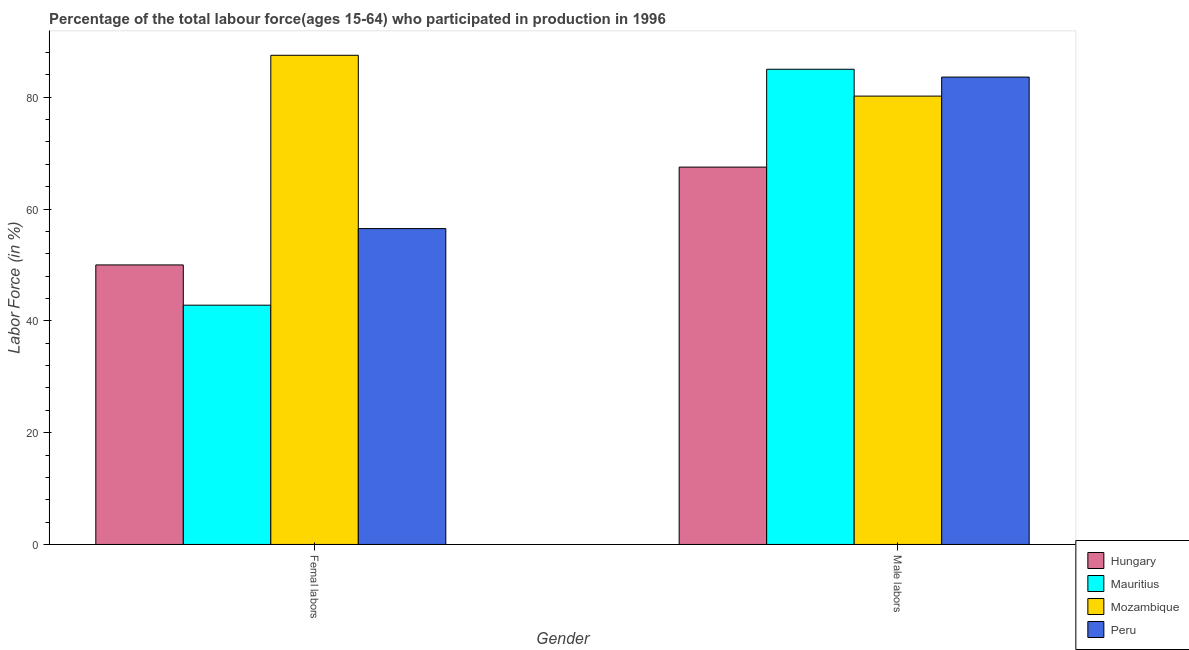How many groups of bars are there?
Offer a terse response. 2. Are the number of bars per tick equal to the number of legend labels?
Give a very brief answer. Yes. What is the label of the 2nd group of bars from the left?
Your response must be concise. Male labors. What is the percentage of female labor force in Peru?
Your answer should be compact. 56.5. Across all countries, what is the maximum percentage of female labor force?
Your response must be concise. 87.5. Across all countries, what is the minimum percentage of male labour force?
Offer a very short reply. 67.5. In which country was the percentage of female labor force maximum?
Give a very brief answer. Mozambique. In which country was the percentage of male labour force minimum?
Ensure brevity in your answer.  Hungary. What is the total percentage of female labor force in the graph?
Offer a very short reply. 236.8. What is the difference between the percentage of male labour force in Mauritius and that in Mozambique?
Make the answer very short. 4.8. What is the difference between the percentage of male labour force in Mozambique and the percentage of female labor force in Peru?
Ensure brevity in your answer.  23.7. What is the average percentage of female labor force per country?
Give a very brief answer. 59.2. What is the difference between the percentage of male labour force and percentage of female labor force in Hungary?
Provide a succinct answer. 17.5. In how many countries, is the percentage of female labor force greater than 28 %?
Give a very brief answer. 4. What is the ratio of the percentage of female labor force in Hungary to that in Peru?
Keep it short and to the point. 0.88. Is the percentage of male labour force in Hungary less than that in Mozambique?
Provide a succinct answer. Yes. What does the 2nd bar from the left in Male labors represents?
Ensure brevity in your answer.  Mauritius. What does the 1st bar from the right in Femal labors represents?
Your answer should be very brief. Peru. How many bars are there?
Your response must be concise. 8. What is the difference between two consecutive major ticks on the Y-axis?
Ensure brevity in your answer.  20. Does the graph contain grids?
Keep it short and to the point. No. How many legend labels are there?
Make the answer very short. 4. What is the title of the graph?
Your answer should be very brief. Percentage of the total labour force(ages 15-64) who participated in production in 1996. Does "Turkey" appear as one of the legend labels in the graph?
Your answer should be compact. No. What is the label or title of the X-axis?
Ensure brevity in your answer.  Gender. What is the label or title of the Y-axis?
Your answer should be very brief. Labor Force (in %). What is the Labor Force (in %) of Mauritius in Femal labors?
Your response must be concise. 42.8. What is the Labor Force (in %) in Mozambique in Femal labors?
Offer a terse response. 87.5. What is the Labor Force (in %) in Peru in Femal labors?
Your answer should be very brief. 56.5. What is the Labor Force (in %) in Hungary in Male labors?
Make the answer very short. 67.5. What is the Labor Force (in %) of Mauritius in Male labors?
Provide a short and direct response. 85. What is the Labor Force (in %) in Mozambique in Male labors?
Provide a succinct answer. 80.2. What is the Labor Force (in %) in Peru in Male labors?
Offer a very short reply. 83.6. Across all Gender, what is the maximum Labor Force (in %) in Hungary?
Provide a succinct answer. 67.5. Across all Gender, what is the maximum Labor Force (in %) of Mauritius?
Your answer should be very brief. 85. Across all Gender, what is the maximum Labor Force (in %) in Mozambique?
Keep it short and to the point. 87.5. Across all Gender, what is the maximum Labor Force (in %) of Peru?
Your response must be concise. 83.6. Across all Gender, what is the minimum Labor Force (in %) in Mauritius?
Keep it short and to the point. 42.8. Across all Gender, what is the minimum Labor Force (in %) in Mozambique?
Give a very brief answer. 80.2. Across all Gender, what is the minimum Labor Force (in %) in Peru?
Keep it short and to the point. 56.5. What is the total Labor Force (in %) in Hungary in the graph?
Keep it short and to the point. 117.5. What is the total Labor Force (in %) of Mauritius in the graph?
Your answer should be compact. 127.8. What is the total Labor Force (in %) in Mozambique in the graph?
Make the answer very short. 167.7. What is the total Labor Force (in %) of Peru in the graph?
Give a very brief answer. 140.1. What is the difference between the Labor Force (in %) in Hungary in Femal labors and that in Male labors?
Offer a very short reply. -17.5. What is the difference between the Labor Force (in %) of Mauritius in Femal labors and that in Male labors?
Make the answer very short. -42.2. What is the difference between the Labor Force (in %) of Mozambique in Femal labors and that in Male labors?
Give a very brief answer. 7.3. What is the difference between the Labor Force (in %) of Peru in Femal labors and that in Male labors?
Your response must be concise. -27.1. What is the difference between the Labor Force (in %) in Hungary in Femal labors and the Labor Force (in %) in Mauritius in Male labors?
Keep it short and to the point. -35. What is the difference between the Labor Force (in %) in Hungary in Femal labors and the Labor Force (in %) in Mozambique in Male labors?
Make the answer very short. -30.2. What is the difference between the Labor Force (in %) in Hungary in Femal labors and the Labor Force (in %) in Peru in Male labors?
Ensure brevity in your answer.  -33.6. What is the difference between the Labor Force (in %) of Mauritius in Femal labors and the Labor Force (in %) of Mozambique in Male labors?
Make the answer very short. -37.4. What is the difference between the Labor Force (in %) of Mauritius in Femal labors and the Labor Force (in %) of Peru in Male labors?
Your answer should be compact. -40.8. What is the average Labor Force (in %) in Hungary per Gender?
Keep it short and to the point. 58.75. What is the average Labor Force (in %) in Mauritius per Gender?
Give a very brief answer. 63.9. What is the average Labor Force (in %) of Mozambique per Gender?
Ensure brevity in your answer.  83.85. What is the average Labor Force (in %) in Peru per Gender?
Provide a short and direct response. 70.05. What is the difference between the Labor Force (in %) of Hungary and Labor Force (in %) of Mauritius in Femal labors?
Provide a short and direct response. 7.2. What is the difference between the Labor Force (in %) of Hungary and Labor Force (in %) of Mozambique in Femal labors?
Give a very brief answer. -37.5. What is the difference between the Labor Force (in %) in Mauritius and Labor Force (in %) in Mozambique in Femal labors?
Your answer should be very brief. -44.7. What is the difference between the Labor Force (in %) in Mauritius and Labor Force (in %) in Peru in Femal labors?
Provide a short and direct response. -13.7. What is the difference between the Labor Force (in %) of Mozambique and Labor Force (in %) of Peru in Femal labors?
Ensure brevity in your answer.  31. What is the difference between the Labor Force (in %) in Hungary and Labor Force (in %) in Mauritius in Male labors?
Offer a very short reply. -17.5. What is the difference between the Labor Force (in %) of Hungary and Labor Force (in %) of Peru in Male labors?
Offer a very short reply. -16.1. What is the difference between the Labor Force (in %) in Mauritius and Labor Force (in %) in Peru in Male labors?
Provide a short and direct response. 1.4. What is the difference between the Labor Force (in %) in Mozambique and Labor Force (in %) in Peru in Male labors?
Offer a terse response. -3.4. What is the ratio of the Labor Force (in %) of Hungary in Femal labors to that in Male labors?
Make the answer very short. 0.74. What is the ratio of the Labor Force (in %) of Mauritius in Femal labors to that in Male labors?
Make the answer very short. 0.5. What is the ratio of the Labor Force (in %) of Mozambique in Femal labors to that in Male labors?
Your answer should be very brief. 1.09. What is the ratio of the Labor Force (in %) of Peru in Femal labors to that in Male labors?
Offer a terse response. 0.68. What is the difference between the highest and the second highest Labor Force (in %) in Mauritius?
Keep it short and to the point. 42.2. What is the difference between the highest and the second highest Labor Force (in %) of Peru?
Your answer should be very brief. 27.1. What is the difference between the highest and the lowest Labor Force (in %) in Mauritius?
Give a very brief answer. 42.2. What is the difference between the highest and the lowest Labor Force (in %) in Peru?
Offer a very short reply. 27.1. 